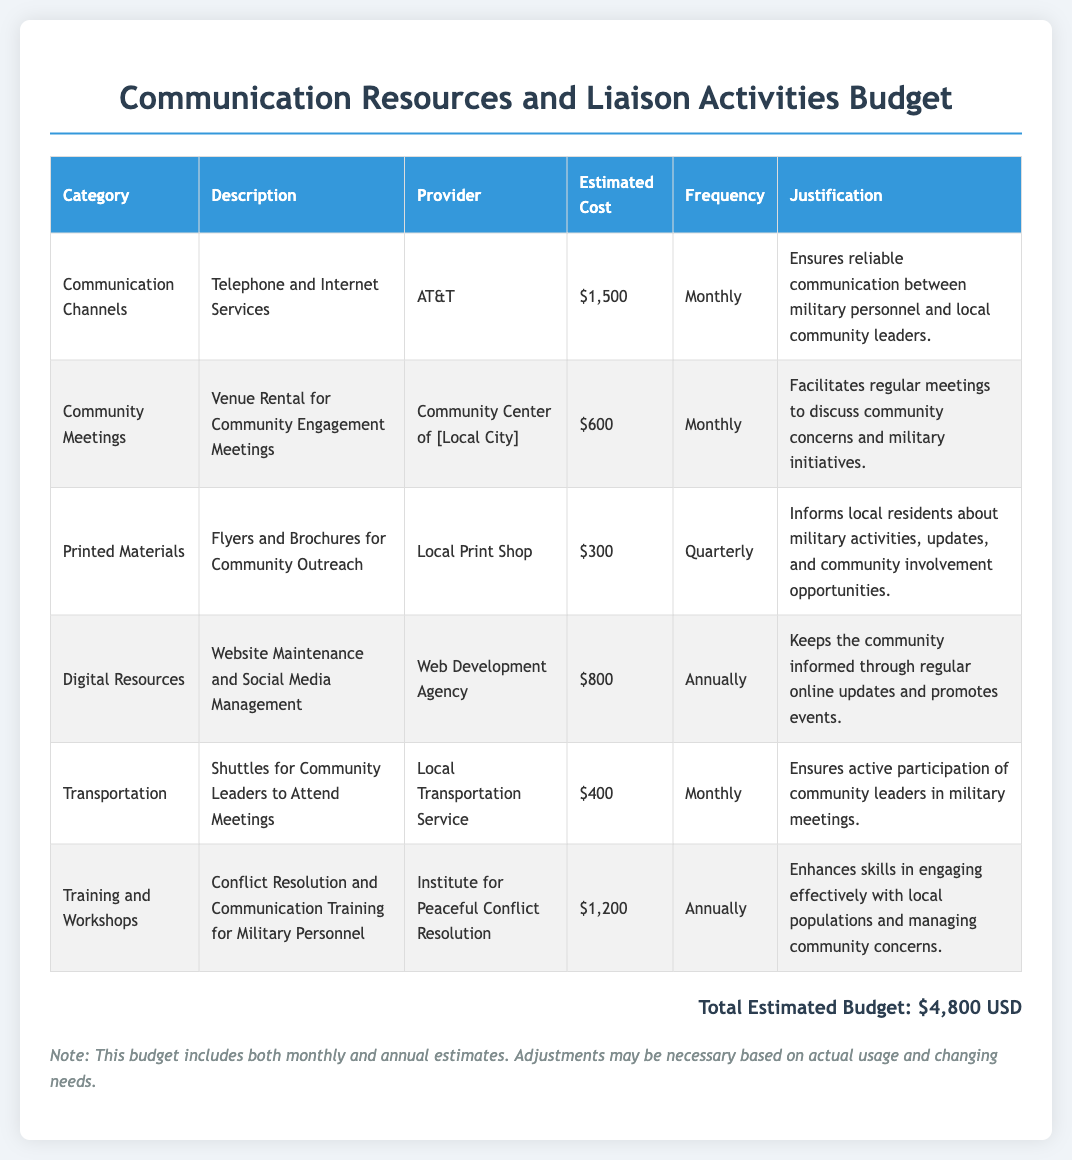What is the estimated cost for telephone and internet services? The estimated cost for telephone and internet services is listed in the communication channels section of the document.
Answer: $1,500 How often are community engagement meetings held? The frequency of community engagement meetings is mentioned in the corresponding section about venue rental.
Answer: Monthly What is the total estimated budget? The total estimated budget can be found at the bottom of the document, summarizing all costs.
Answer: $4,800 USD Who provides printed materials for community outreach? The provider of printed materials is specified in the printed materials section of the budget document.
Answer: Local Print Shop What type of training is included in this budget? The type of training is described in the training and workshops section, detailing the focus of the training.
Answer: Conflict Resolution and Communication Training How much is allocated for website maintenance and social media management? The amount allocated can be extracted from the digital resources section.
Answer: $800 Why is transportation included in the budget? The justification for transportation can be found in the transportation section of the document.
Answer: Ensures active participation of community leaders What is the frequency of printing flyers and brochures? The frequency of printing flyers and brochures is noted in the printed materials section of the budget.
Answer: Quarterly Who provides the training for military personnel? The provider for the training session can be found in the training and workshops portion of the document.
Answer: Institute for Peaceful Conflict Resolution 